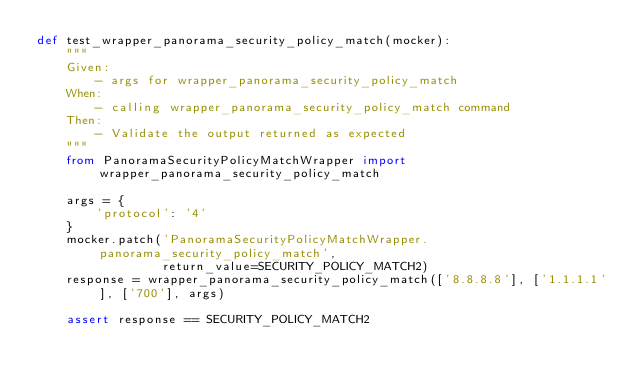Convert code to text. <code><loc_0><loc_0><loc_500><loc_500><_Python_>def test_wrapper_panorama_security_policy_match(mocker):
    """
    Given:
        - args for wrapper_panorama_security_policy_match
    When:
        - calling wrapper_panorama_security_policy_match command
    Then:
        - Validate the output returned as expected
    """
    from PanoramaSecurityPolicyMatchWrapper import wrapper_panorama_security_policy_match

    args = {
        'protocol': '4'
    }
    mocker.patch('PanoramaSecurityPolicyMatchWrapper.panorama_security_policy_match',
                 return_value=SECURITY_POLICY_MATCH2)
    response = wrapper_panorama_security_policy_match(['8.8.8.8'], ['1.1.1.1'], ['700'], args)

    assert response == SECURITY_POLICY_MATCH2
</code> 